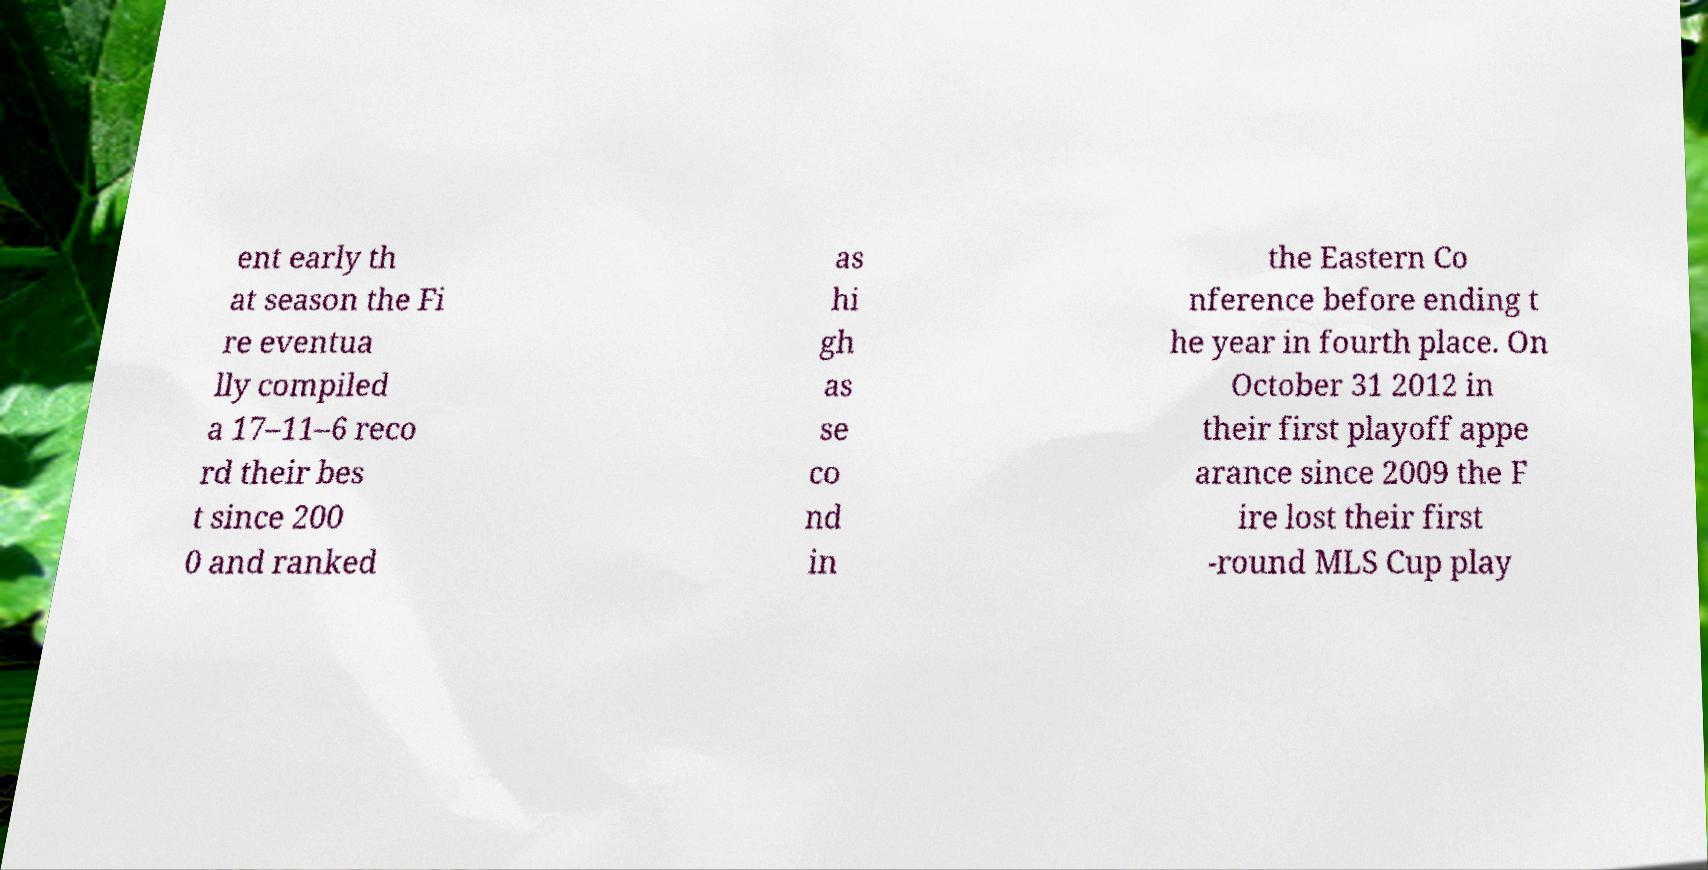What messages or text are displayed in this image? I need them in a readable, typed format. ent early th at season the Fi re eventua lly compiled a 17–11–6 reco rd their bes t since 200 0 and ranked as hi gh as se co nd in the Eastern Co nference before ending t he year in fourth place. On October 31 2012 in their first playoff appe arance since 2009 the F ire lost their first -round MLS Cup play 